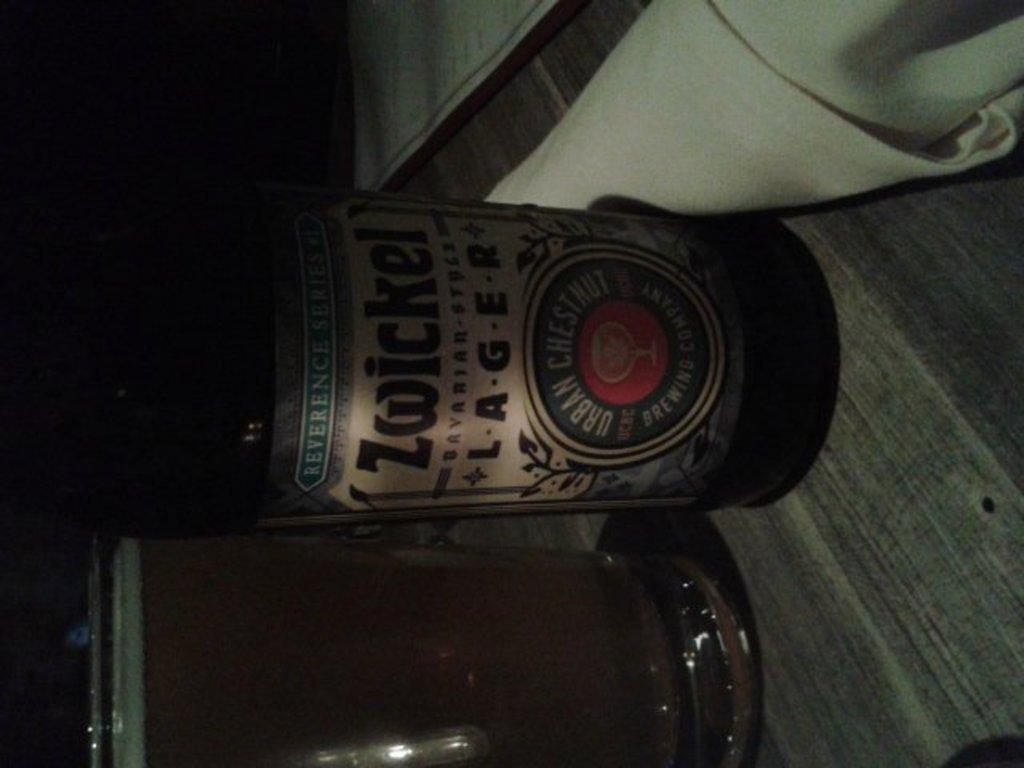<image>
Share a concise interpretation of the image provided. A bottle of Zwickel lager next to a filled glass. 